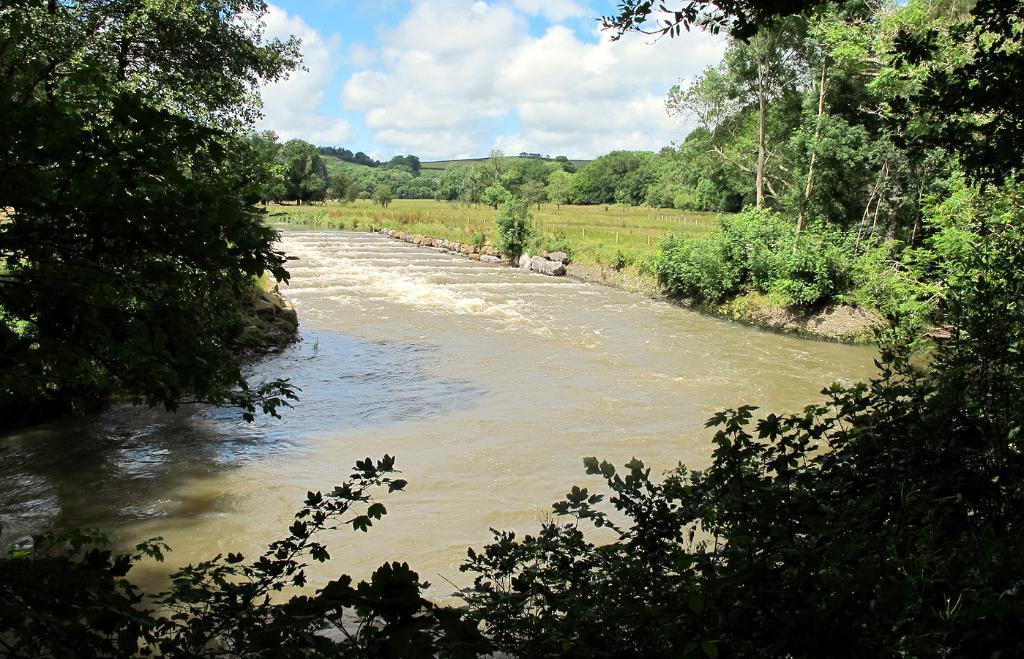Could you give a brief overview of what you see in this image? In this image I can see in the middle water is flowing, there are trees on either side of this image at the top there is the sky. 